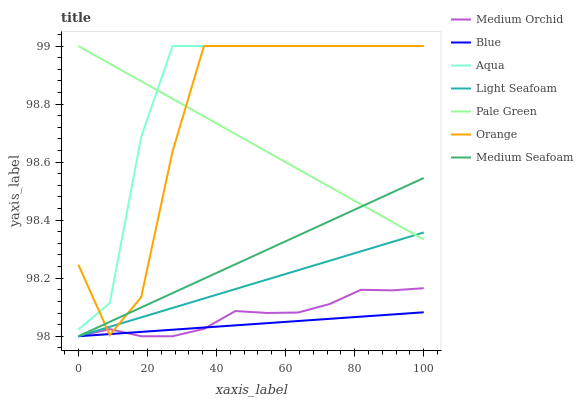Does Blue have the minimum area under the curve?
Answer yes or no. Yes. Does Aqua have the maximum area under the curve?
Answer yes or no. Yes. Does Medium Orchid have the minimum area under the curve?
Answer yes or no. No. Does Medium Orchid have the maximum area under the curve?
Answer yes or no. No. Is Blue the smoothest?
Answer yes or no. Yes. Is Orange the roughest?
Answer yes or no. Yes. Is Medium Orchid the smoothest?
Answer yes or no. No. Is Medium Orchid the roughest?
Answer yes or no. No. Does Blue have the lowest value?
Answer yes or no. Yes. Does Aqua have the lowest value?
Answer yes or no. No. Does Orange have the highest value?
Answer yes or no. Yes. Does Medium Orchid have the highest value?
Answer yes or no. No. Is Blue less than Aqua?
Answer yes or no. Yes. Is Pale Green greater than Medium Orchid?
Answer yes or no. Yes. Does Light Seafoam intersect Medium Seafoam?
Answer yes or no. Yes. Is Light Seafoam less than Medium Seafoam?
Answer yes or no. No. Is Light Seafoam greater than Medium Seafoam?
Answer yes or no. No. Does Blue intersect Aqua?
Answer yes or no. No. 